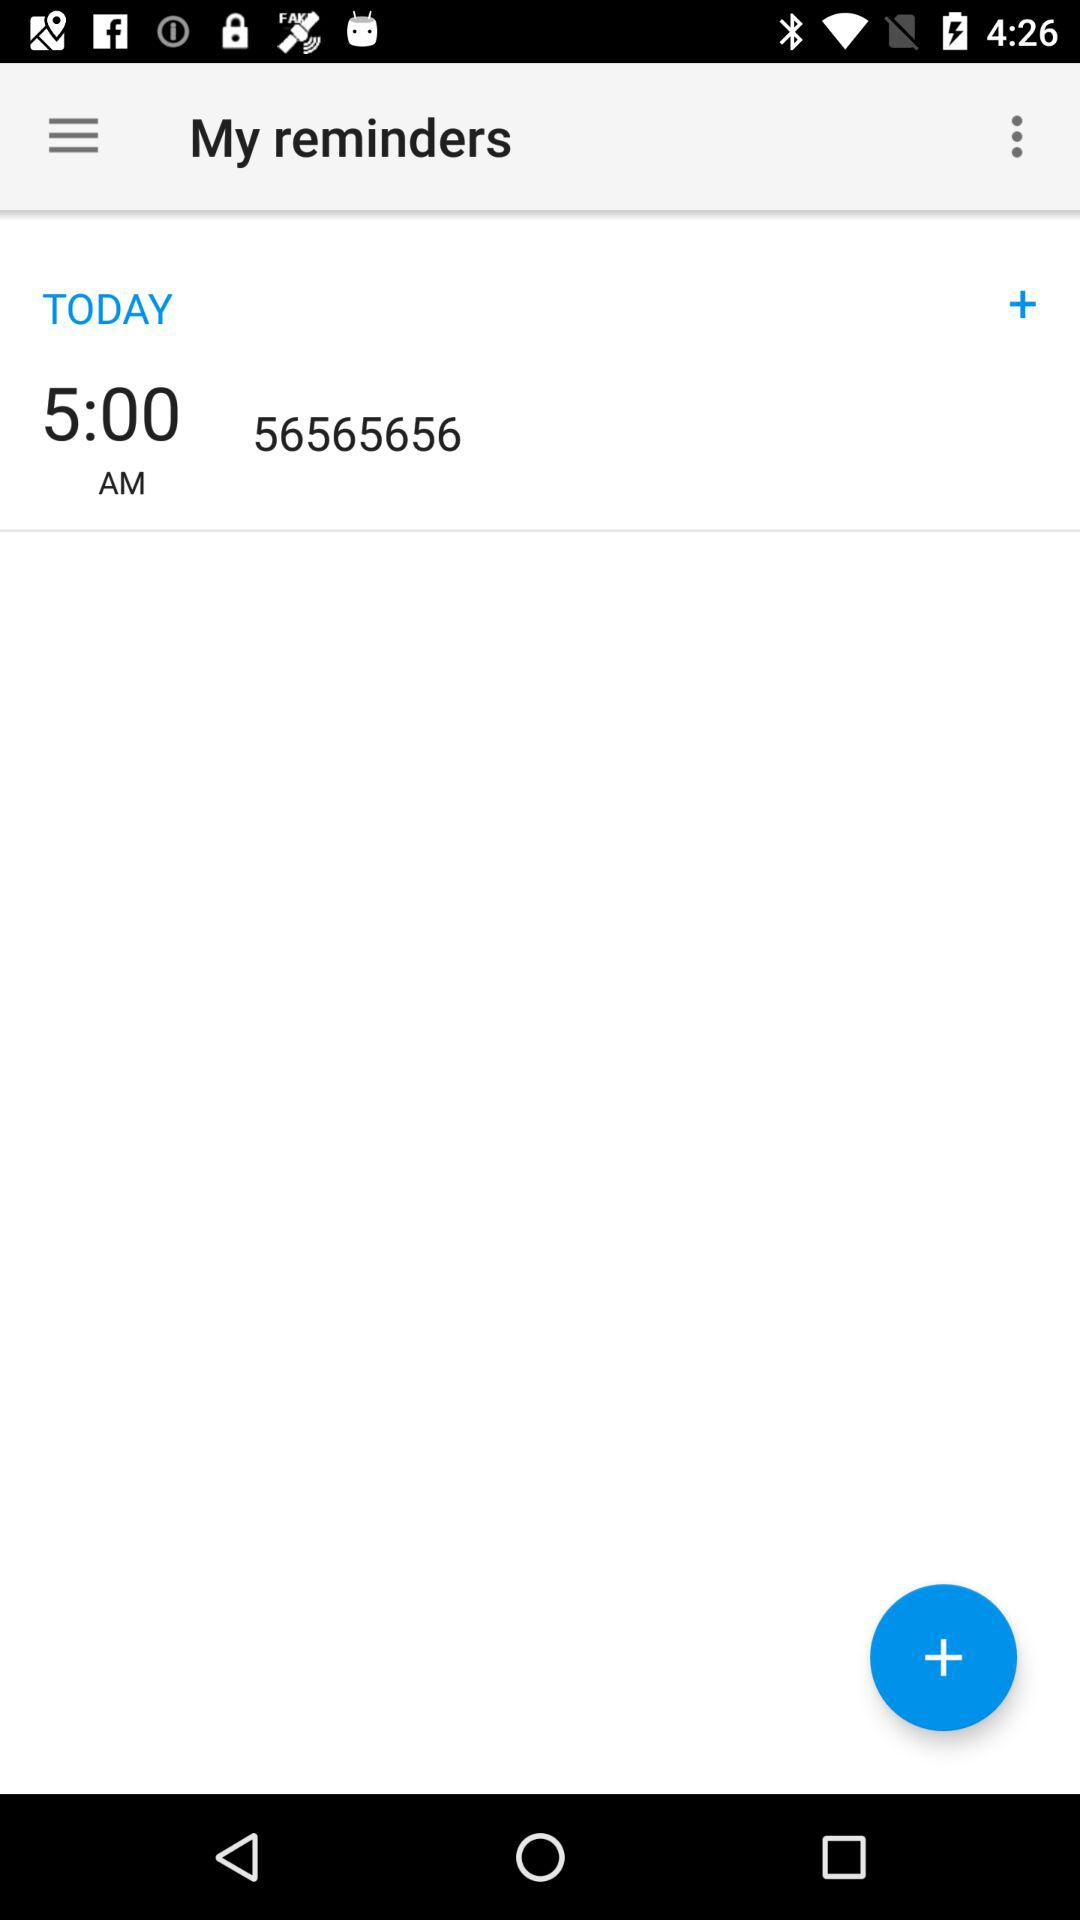What is the time? The time is 5:00 AM. 